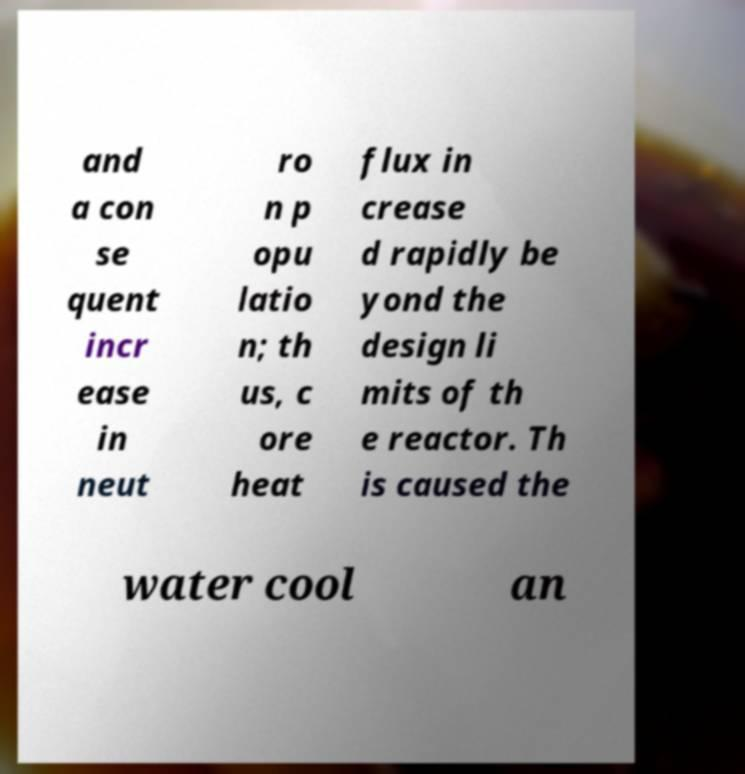There's text embedded in this image that I need extracted. Can you transcribe it verbatim? and a con se quent incr ease in neut ro n p opu latio n; th us, c ore heat flux in crease d rapidly be yond the design li mits of th e reactor. Th is caused the water cool an 